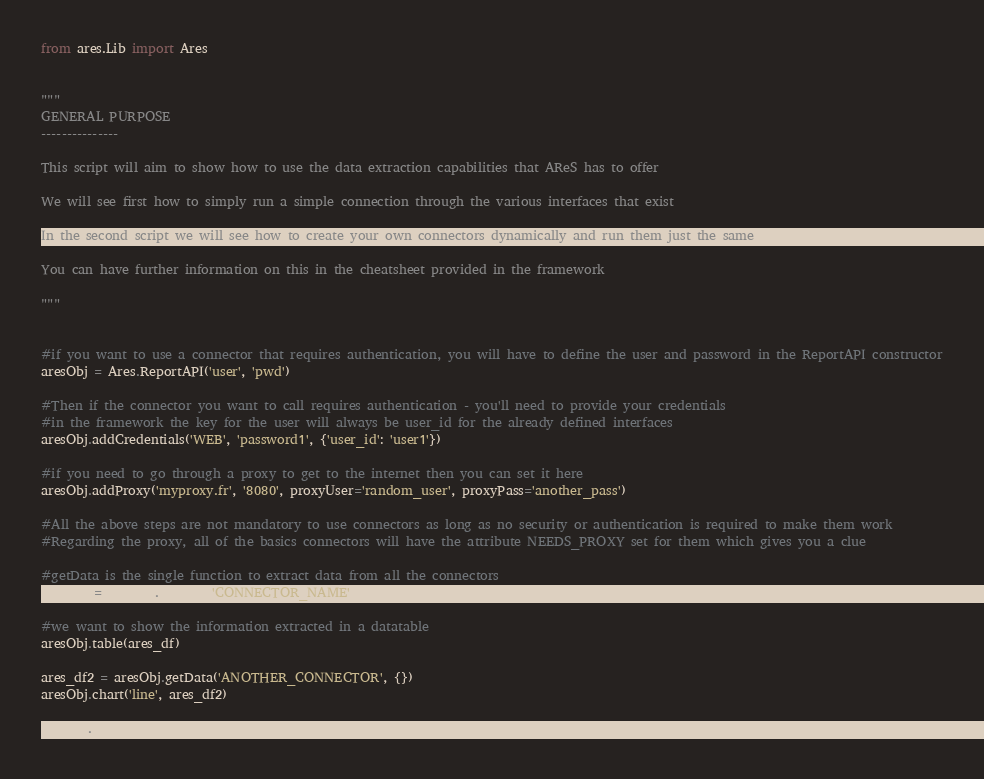Convert code to text. <code><loc_0><loc_0><loc_500><loc_500><_Python_>from ares.Lib import Ares


"""
GENERAL PURPOSE
---------------

This script will aim to show how to use the data extraction capabilities that AReS has to offer

We will see first how to simply run a simple connection through the various interfaces that exist

In the second script we will see how to create your own connectors dynamically and run them just the same

You can have further information on this in the cheatsheet provided in the framework

"""


#if you want to use a connector that requires authentication, you will have to define the user and password in the ReportAPI constructor
aresObj = Ares.ReportAPI('user', 'pwd')

#Then if the connector you want to call requires authentication - you'll need to provide your credentials
#in the framework the key for the user will always be user_id for the already defined interfaces
aresObj.addCredentials('WEB', 'password1', {'user_id': 'user1'})

#if you need to go through a proxy to get to the internet then you can set it here
aresObj.addProxy('myproxy.fr', '8080', proxyUser='random_user', proxyPass='another_pass')

#All the above steps are not mandatory to use connectors as long as no security or authentication is required to make them work
#Regarding the proxy, all of the basics connectors will have the attribute NEEDS_PROXY set for them which gives you a clue

#getData is the single function to extract data from all the connectors
ares_df = aresObj.getData('CONNECTOR_NAME', {})

#we want to show the information extracted in a datatable
aresObj.table(ares_df)

ares_df2 = aresObj.getData('ANOTHER_CONNECTOR', {})
aresObj.chart('line', ares_df2)

aresObj.toHtml()</code> 